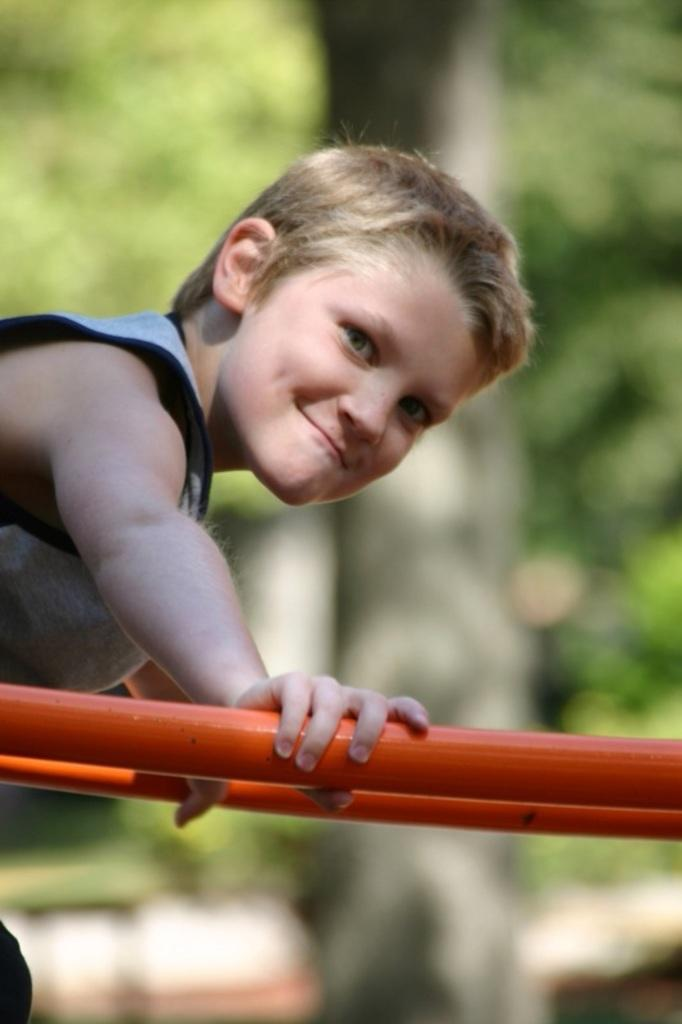What is the person on the left side of the image doing? The person is holding a metal rod and giving a pose for the picture. What is the person's facial expression in the image? The person is smiling in the image. What can be seen in the background of the image? The background of the image is blurred. What type of lock is the person using to secure the oatmeal in the image? There is no lock or oatmeal present in the image. What property does the person own in the image? There is no information about the person owning any property in the image. 